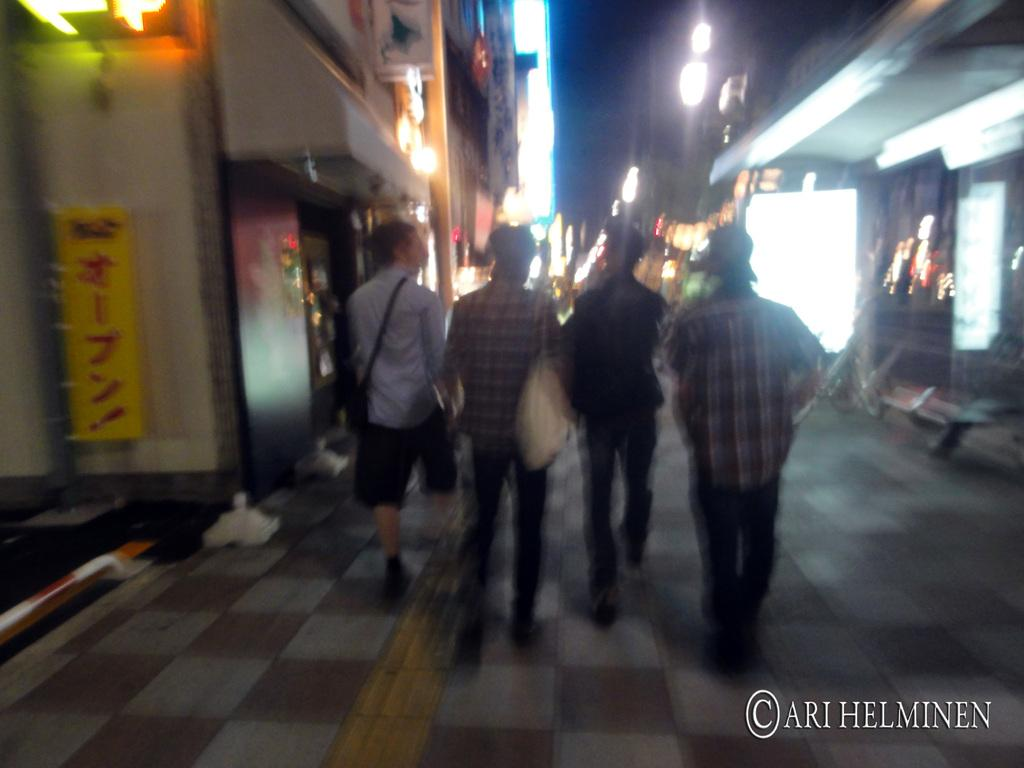What are the people in the image doing? The people in the image are walking on the floor. What can be seen in the background of the image? There are buildings with lights in the image. What is written on the board in the image? There is a board with text on the wall of a building in the image. Can you see any sea creatures swimming in the image? There is no sea or sea creatures present in the image. What type of tramp is visible in the image? There is no tramp present in the image. 